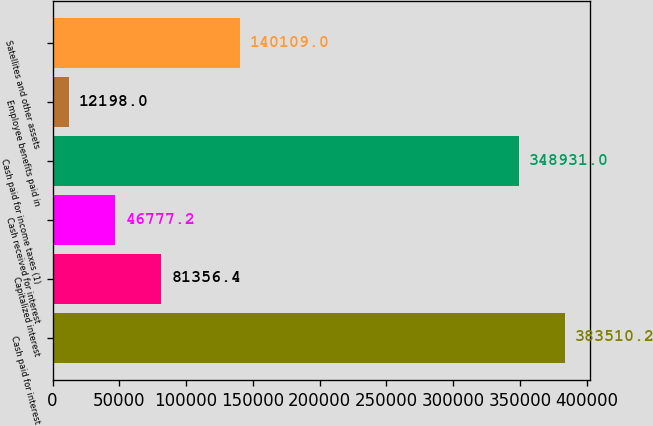Convert chart. <chart><loc_0><loc_0><loc_500><loc_500><bar_chart><fcel>Cash paid for interest<fcel>Capitalized interest<fcel>Cash received for interest<fcel>Cash paid for income taxes (1)<fcel>Employee benefits paid in<fcel>Satellites and other assets<nl><fcel>383510<fcel>81356.4<fcel>46777.2<fcel>348931<fcel>12198<fcel>140109<nl></chart> 